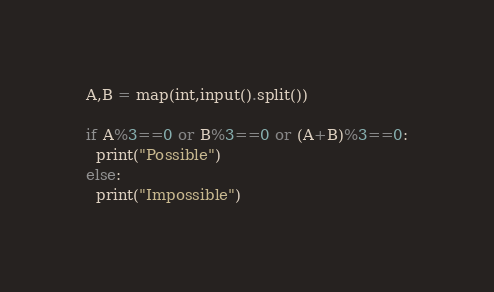Convert code to text. <code><loc_0><loc_0><loc_500><loc_500><_Python_>A,B = map(int,input().split())

if A%3==0 or B%3==0 or (A+B)%3==0:
  print("Possible")
else:
  print("Impossible")</code> 